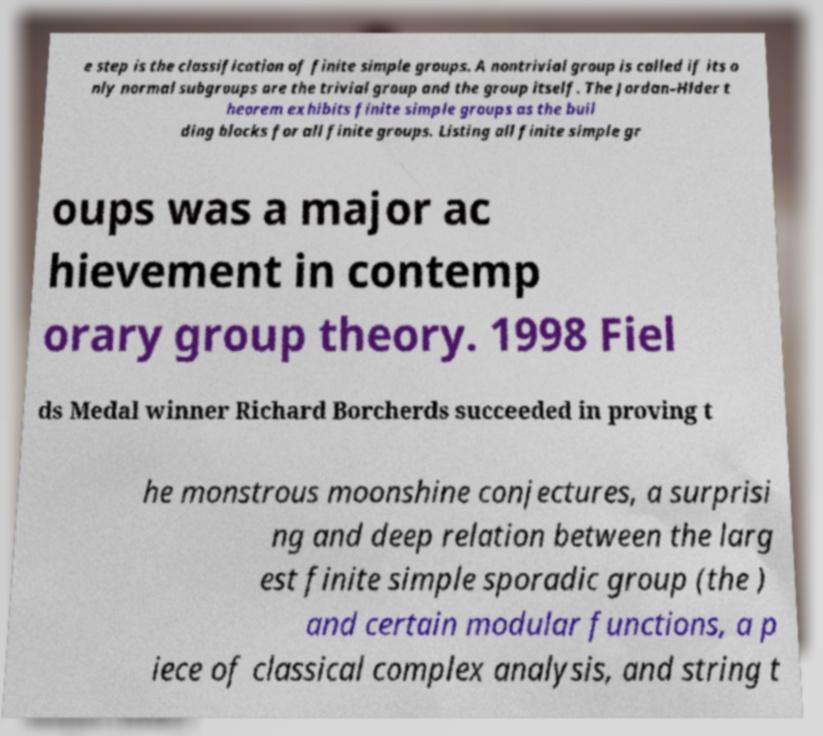Can you read and provide the text displayed in the image?This photo seems to have some interesting text. Can you extract and type it out for me? e step is the classification of finite simple groups. A nontrivial group is called if its o nly normal subgroups are the trivial group and the group itself. The Jordan–Hlder t heorem exhibits finite simple groups as the buil ding blocks for all finite groups. Listing all finite simple gr oups was a major ac hievement in contemp orary group theory. 1998 Fiel ds Medal winner Richard Borcherds succeeded in proving t he monstrous moonshine conjectures, a surprisi ng and deep relation between the larg est finite simple sporadic group (the ) and certain modular functions, a p iece of classical complex analysis, and string t 